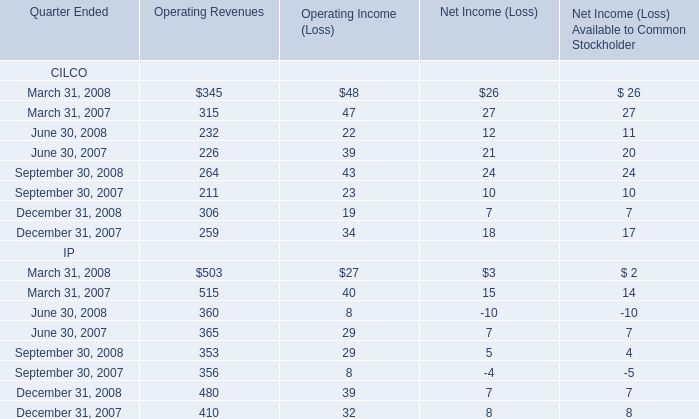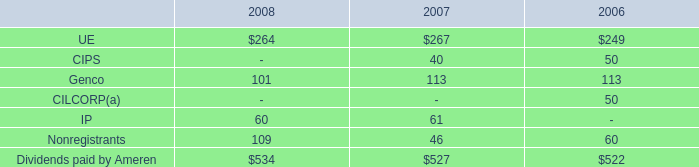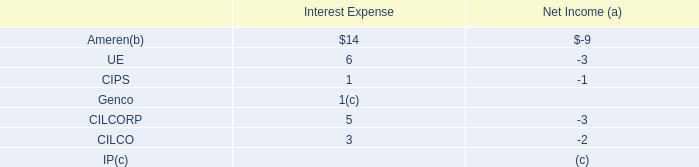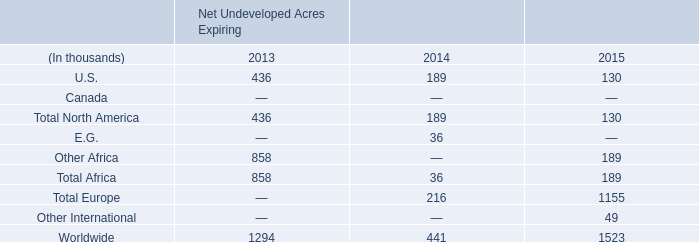What will Operating Revenues of CILCO be like in 2009 if it develops with the same increasing rate as current? 
Computations: ((1 + (((((345 + 232) + 264) + 306) - (((315 + 226) + 211) + 259)) / (((315 + 226) + 211) + 259))) * (((345 + 232) + 264) + 306))
Answer: 1301.29476. 